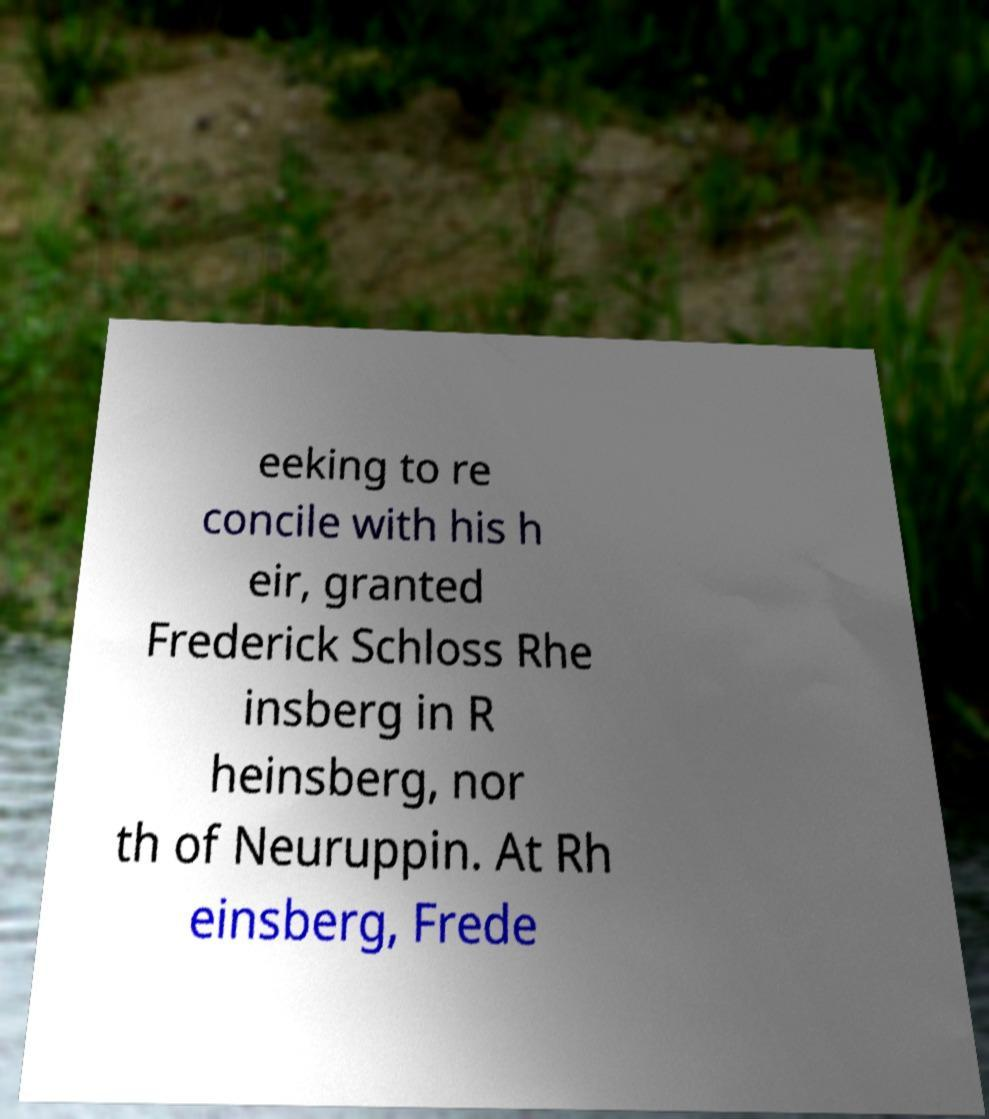What messages or text are displayed in this image? I need them in a readable, typed format. eeking to re concile with his h eir, granted Frederick Schloss Rhe insberg in R heinsberg, nor th of Neuruppin. At Rh einsberg, Frede 